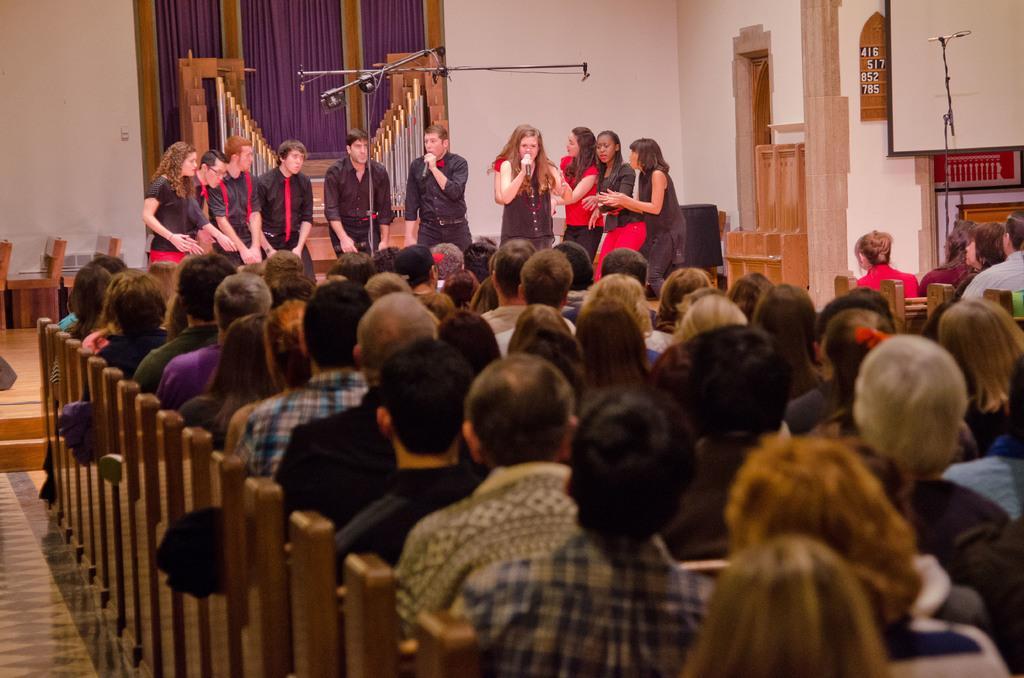Please provide a concise description of this image. Here in this picture, in the front we can see number of people sitting on the benches present on the floor and in front of them we can see a group of men and woman standing on the stage and singing songs with microphones in their hands and on the left side we can see chairs present and behind them we can see curtains present and on the right side we can see a door present and beside that we can see a rack present. 